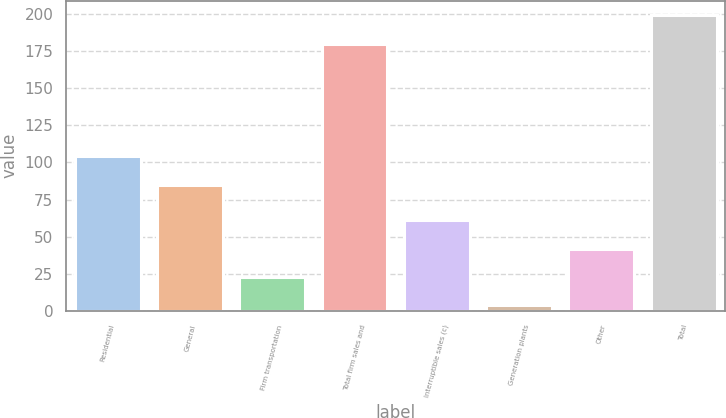Convert chart. <chart><loc_0><loc_0><loc_500><loc_500><bar_chart><fcel>Residential<fcel>General<fcel>Firm transportation<fcel>Total firm sales and<fcel>Interruptible sales (c)<fcel>Generation plants<fcel>Other<fcel>Total<nl><fcel>104<fcel>85<fcel>23<fcel>180<fcel>61<fcel>4<fcel>42<fcel>199<nl></chart> 